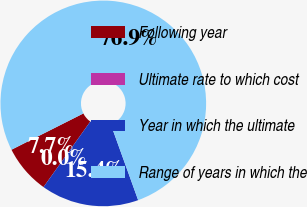<chart> <loc_0><loc_0><loc_500><loc_500><pie_chart><fcel>Following year<fcel>Ultimate rate to which cost<fcel>Year in which the ultimate<fcel>Range of years in which the<nl><fcel>7.69%<fcel>0.0%<fcel>15.38%<fcel>76.92%<nl></chart> 